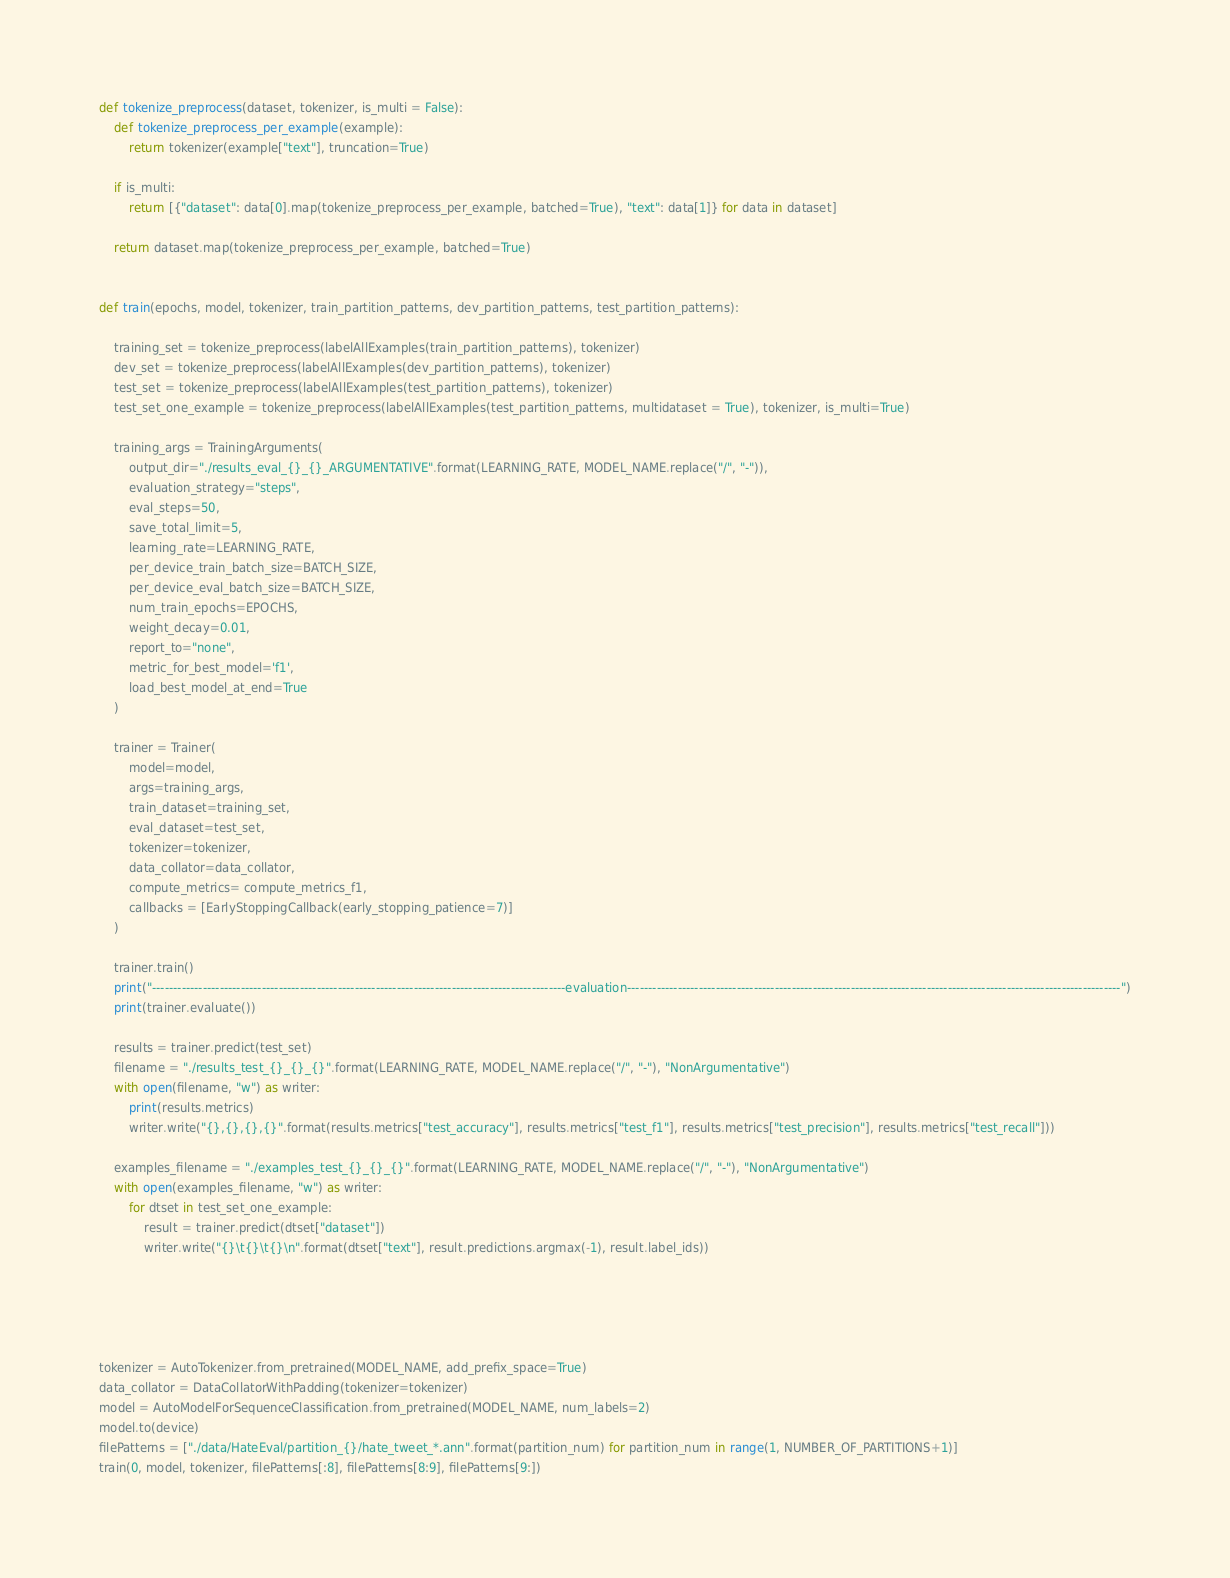Convert code to text. <code><loc_0><loc_0><loc_500><loc_500><_Python_>

def tokenize_preprocess(dataset, tokenizer, is_multi = False):
    def tokenize_preprocess_per_example(example):
        return tokenizer(example["text"], truncation=True)

    if is_multi:
        return [{"dataset": data[0].map(tokenize_preprocess_per_example, batched=True), "text": data[1]} for data in dataset]

    return dataset.map(tokenize_preprocess_per_example, batched=True)


def train(epochs, model, tokenizer, train_partition_patterns, dev_partition_patterns, test_partition_patterns):

    training_set = tokenize_preprocess(labelAllExamples(train_partition_patterns), tokenizer)
    dev_set = tokenize_preprocess(labelAllExamples(dev_partition_patterns), tokenizer)
    test_set = tokenize_preprocess(labelAllExamples(test_partition_patterns), tokenizer)
    test_set_one_example = tokenize_preprocess(labelAllExamples(test_partition_patterns, multidataset = True), tokenizer, is_multi=True)
    
    training_args = TrainingArguments(
        output_dir="./results_eval_{}_{}_ARGUMENTATIVE".format(LEARNING_RATE, MODEL_NAME.replace("/", "-")),
        evaluation_strategy="steps",
        eval_steps=50,
        save_total_limit=5,
        learning_rate=LEARNING_RATE,
        per_device_train_batch_size=BATCH_SIZE,
        per_device_eval_batch_size=BATCH_SIZE,
        num_train_epochs=EPOCHS,
        weight_decay=0.01,
        report_to="none",
        metric_for_best_model='f1',
        load_best_model_at_end=True
    )

    trainer = Trainer(
        model=model,
        args=training_args,
        train_dataset=training_set,
        eval_dataset=test_set,
        tokenizer=tokenizer,
        data_collator=data_collator,
        compute_metrics= compute_metrics_f1,
        callbacks = [EarlyStoppingCallback(early_stopping_patience=7)]
    ) 

    trainer.train()
    print("--------------------------------------------------------------------------------------------------evaluation---------------------------------------------------------------------------------------------------------------------")
    print(trainer.evaluate())

    results = trainer.predict(test_set)
    filename = "./results_test_{}_{}_{}".format(LEARNING_RATE, MODEL_NAME.replace("/", "-"), "NonArgumentative")
    with open(filename, "w") as writer:
        print(results.metrics)
        writer.write("{},{},{},{}".format(results.metrics["test_accuracy"], results.metrics["test_f1"], results.metrics["test_precision"], results.metrics["test_recall"]))

    examples_filename = "./examples_test_{}_{}_{}".format(LEARNING_RATE, MODEL_NAME.replace("/", "-"), "NonArgumentative")
    with open(examples_filename, "w") as writer:
        for dtset in test_set_one_example:
            result = trainer.predict(dtset["dataset"])
            writer.write("{}\t{}\t{}\n".format(dtset["text"], result.predictions.argmax(-1), result.label_ids))
    
        
        


tokenizer = AutoTokenizer.from_pretrained(MODEL_NAME, add_prefix_space=True)
data_collator = DataCollatorWithPadding(tokenizer=tokenizer)
model = AutoModelForSequenceClassification.from_pretrained(MODEL_NAME, num_labels=2)
model.to(device)
filePatterns = ["./data/HateEval/partition_{}/hate_tweet_*.ann".format(partition_num) for partition_num in range(1, NUMBER_OF_PARTITIONS+1)]
train(0, model, tokenizer, filePatterns[:8], filePatterns[8:9], filePatterns[9:])


</code> 